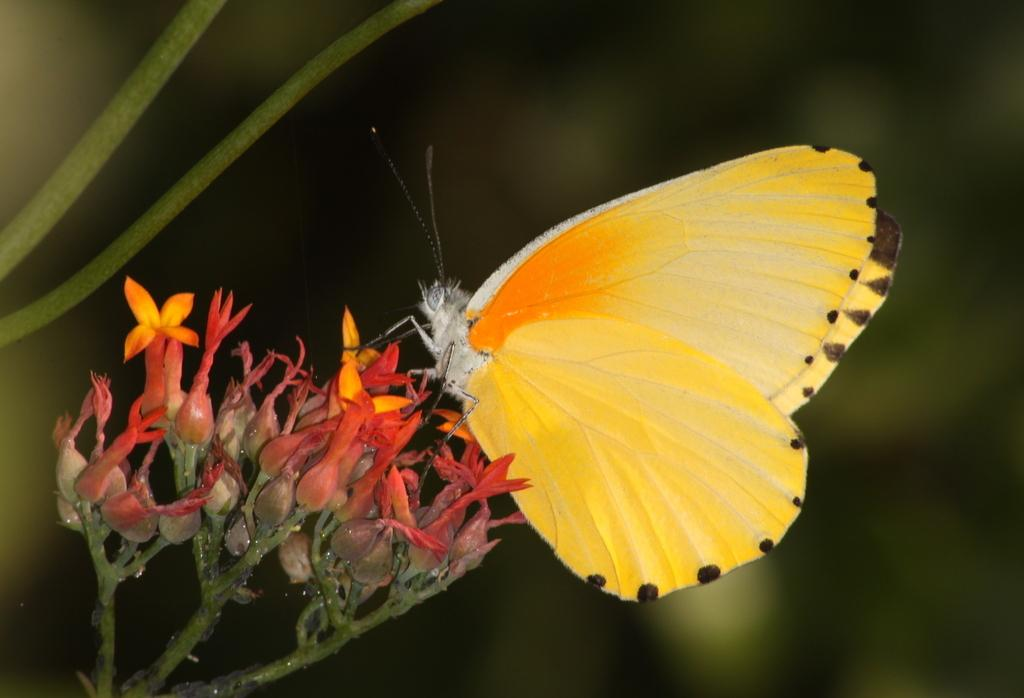What is on the flowers in the image? There is a butterfly on the flowers in the image. What stage of growth are the flowers in? There are buds in the image, which suggests that the flowers are in the early stages of growth. What part of the flowers is visible in the image? There are stems in the image, which indicates that the stalks of the flowers are visible. How would you describe the background of the image? The background of the image is blurred, which could be due to a shallow depth of field or a focus on the foreground. What type of island can be seen in the background of the image? There is no island present in the image; the background is blurred and does not show any landmasses. What appliance is being used by the monkey in the image? There is no monkey or appliance present in the image; it features a butterfly on flowers with a blurred background. 